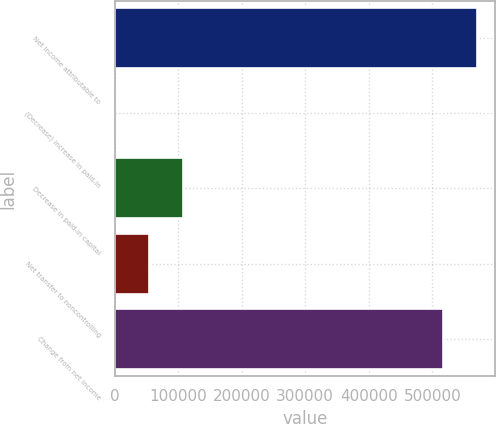Convert chart. <chart><loc_0><loc_0><loc_500><loc_500><bar_chart><fcel>Net income attributable to<fcel>(Decrease) increase in paid-in<fcel>Decrease in paid-in capital<fcel>Net transfer to noncontrolling<fcel>Change from net income<nl><fcel>569882<fcel>1064<fcel>108055<fcel>54559.3<fcel>516387<nl></chart> 